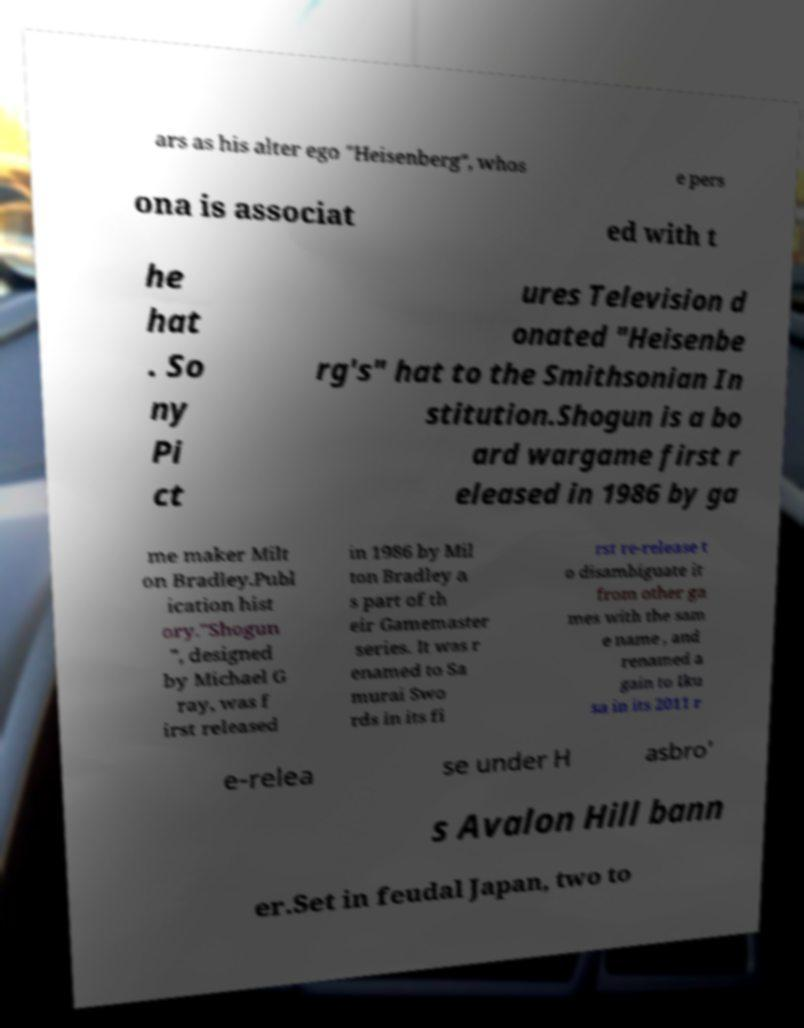Could you assist in decoding the text presented in this image and type it out clearly? ars as his alter ego "Heisenberg", whos e pers ona is associat ed with t he hat . So ny Pi ct ures Television d onated "Heisenbe rg's" hat to the Smithsonian In stitution.Shogun is a bo ard wargame first r eleased in 1986 by ga me maker Milt on Bradley.Publ ication hist ory."Shogun ", designed by Michael G ray, was f irst released in 1986 by Mil ton Bradley a s part of th eir Gamemaster series. It was r enamed to Sa murai Swo rds in its fi rst re-release t o disambiguate it from other ga mes with the sam e name , and renamed a gain to Iku sa in its 2011 r e-relea se under H asbro' s Avalon Hill bann er.Set in feudal Japan, two to 